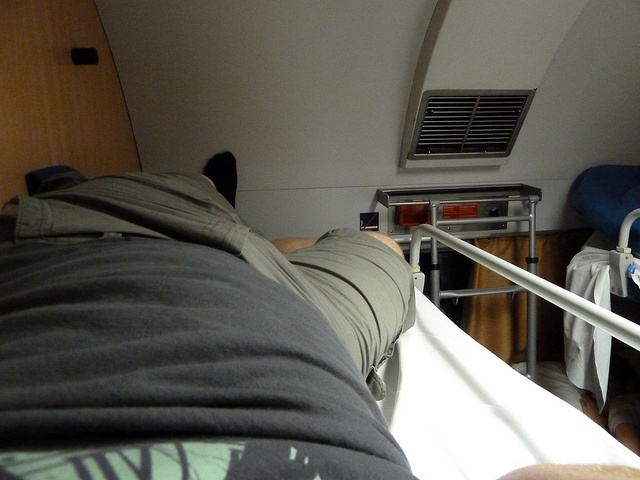Describe the objects in this image and their specific colors. I can see people in maroon, black, gray, and darkgray tones, bed in maroon, white, darkgray, lightgray, and gray tones, and bed in maroon, black, gray, and navy tones in this image. 